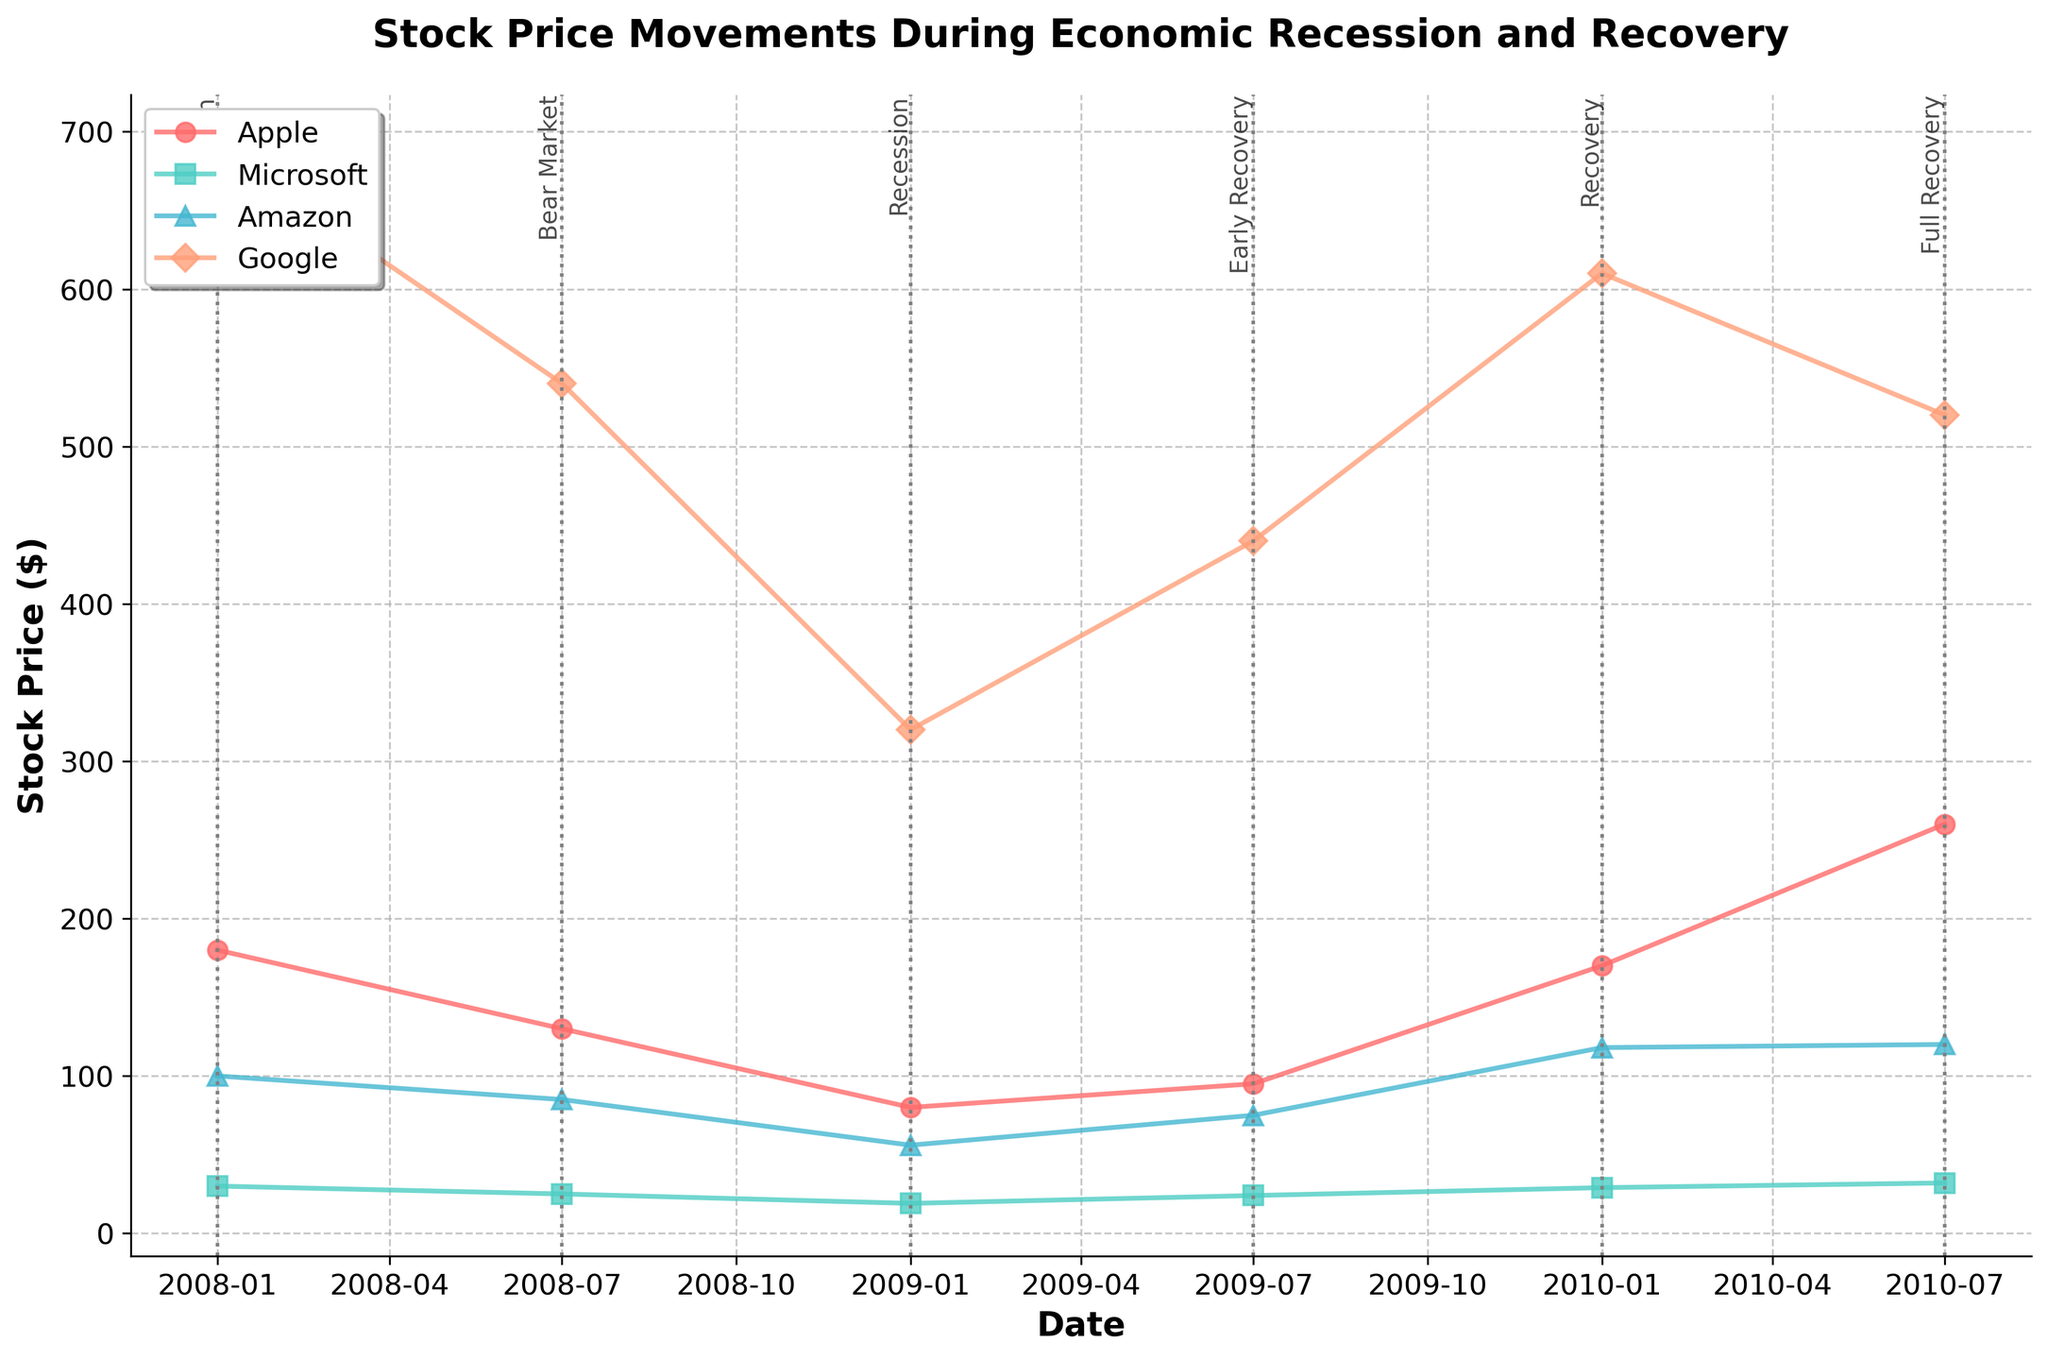What is the title of the plot? The title is displayed at the top of the plot as the main heading. It reads "Stock Price Movements During Economic Recession and Recovery".
Answer: Stock Price Movements During Economic Recession and Recovery How many companies are shown in the plot? There are distinct lines representing the stock prices of different companies. Each line is labeled with the company name in the legend. There are four company names in the legend.
Answer: 4 Which event had the lowest stock price for Amazon? By examining Amazon's (the green line) stock price across the different events, the lowest stock price is observed during the "Recession" event in early 2009.
Answer: Recession During which event did Apple experience the highest stock price? Observing Apple's (the red line) stock prices, the highest point is during the "Full Recovery" phase in mid-2010.
Answer: Full Recovery Plot lines for which companies cross during the plot period? By tracing each line, the lines for Microsoft and Amazon intersect around early 2010.
Answer: Microsoft and Amazon Which company showed a significant drop in stock price during the recession but didn't fully recover by mid-2010? By evaluating the recovery lines of each company, Google (the blue line) saw a significant drop during the recession and did not fully return to pre-recession levels by mid-2010.
Answer: Google What is the average recovery stock price of Apple and Microsoft? Summing the recovery stock prices of Apple (170.00) and Microsoft (29.00) and then dividing by 2 gives (170.00 + 29.00) / 2.
Answer: 99.5 Comparing Amazon and Google, which company had a higher stock price during the Full Recovery event? By referring to the "Full Recovery" points for both companies on the plot, Google had a stock price of 520.00, whereas Amazon had a stock price of 120.00.
Answer: Google What was the difference in stock price for Microsoft between the Recession and Full Recovery events? Identifying the stock prices for Microsoft during the Recession (19.00) and Full Recovery (32.00), the difference is calculated as 32.00 - 19.00.
Answer: 13.00 How did the stock price of Apple change from the Bear Market to the Recovery period? Looking at Apple's stock price, it decreased from 180.00 in pre-recession to 130.00 in the bear market and then further to 80.00 during the recession before starting to rise again. By the recovery period, it reached 170.00. The overall change from the bear market to recovery is 170.00 - 130.00.
Answer: 40.00 